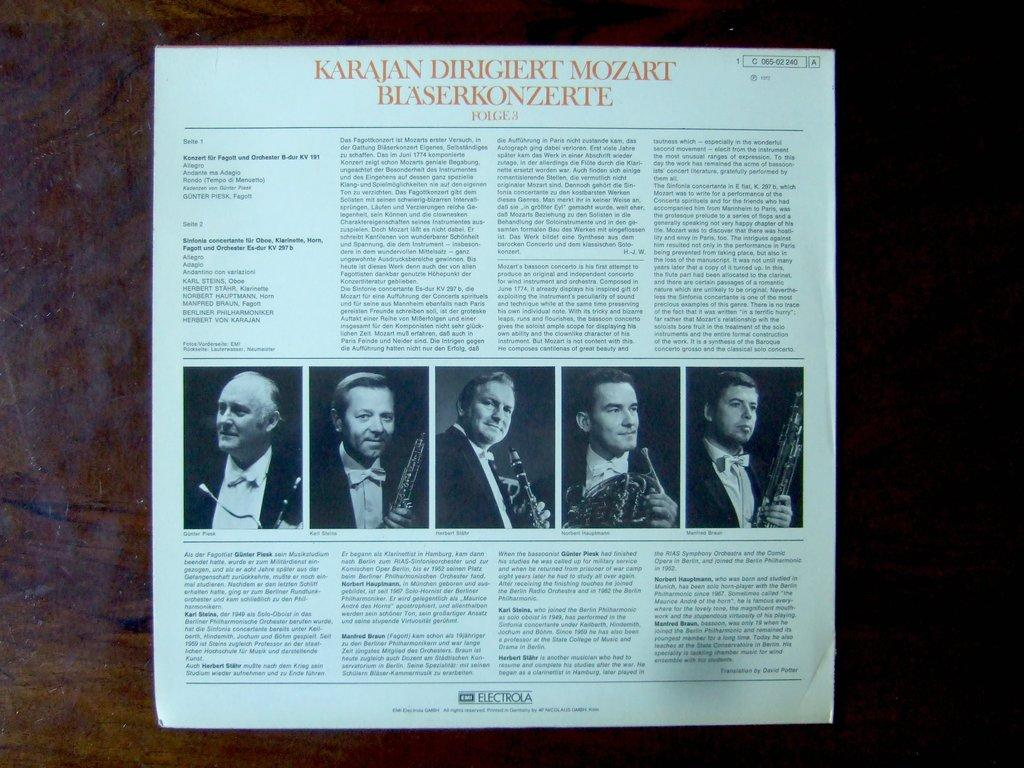What is the main object in the center of the image? There is a magazine in the center of the image. What can be found within the magazine? The magazine contains photos and text. What type of linen is used to cover the train tracks in the image? There is no linen or train tracks present in the image; it features a magazine with photos and text. 